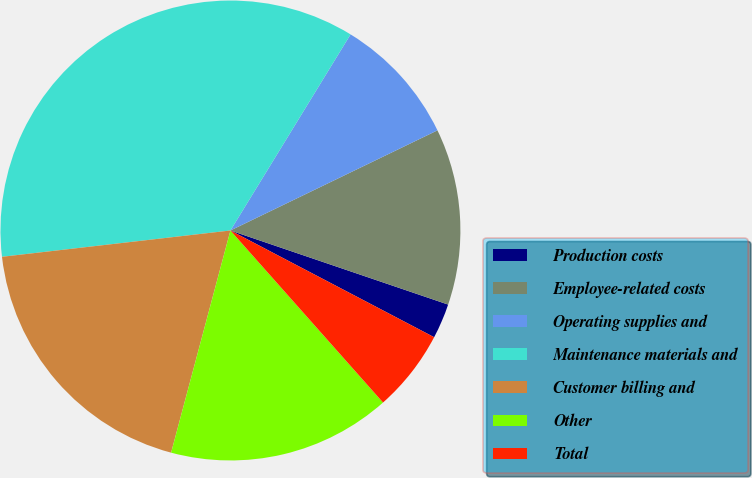<chart> <loc_0><loc_0><loc_500><loc_500><pie_chart><fcel>Production costs<fcel>Employee-related costs<fcel>Operating supplies and<fcel>Maintenance materials and<fcel>Customer billing and<fcel>Other<fcel>Total<nl><fcel>2.46%<fcel>12.39%<fcel>9.08%<fcel>35.57%<fcel>19.02%<fcel>15.7%<fcel>5.77%<nl></chart> 